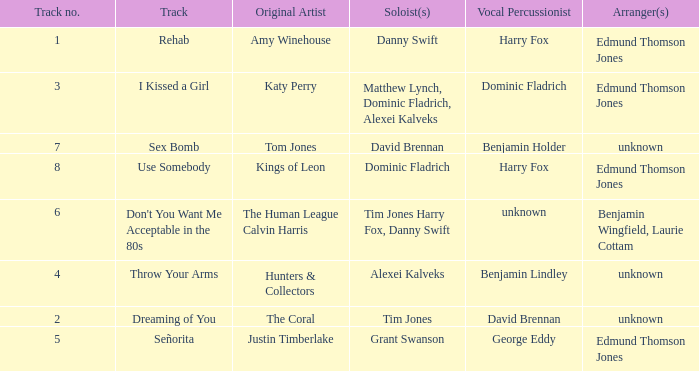Could you parse the entire table? {'header': ['Track no.', 'Track', 'Original Artist', 'Soloist(s)', 'Vocal Percussionist', 'Arranger(s)'], 'rows': [['1', 'Rehab', 'Amy Winehouse', 'Danny Swift', 'Harry Fox', 'Edmund Thomson Jones'], ['3', 'I Kissed a Girl', 'Katy Perry', 'Matthew Lynch, Dominic Fladrich, Alexei Kalveks', 'Dominic Fladrich', 'Edmund Thomson Jones'], ['7', 'Sex Bomb', 'Tom Jones', 'David Brennan', 'Benjamin Holder', 'unknown'], ['8', 'Use Somebody', 'Kings of Leon', 'Dominic Fladrich', 'Harry Fox', 'Edmund Thomson Jones'], ['6', "Don't You Want Me Acceptable in the 80s", 'The Human League Calvin Harris', 'Tim Jones Harry Fox, Danny Swift', 'unknown', 'Benjamin Wingfield, Laurie Cottam'], ['4', 'Throw Your Arms', 'Hunters & Collectors', 'Alexei Kalveks', 'Benjamin Lindley', 'unknown'], ['2', 'Dreaming of You', 'The Coral', 'Tim Jones', 'David Brennan', 'unknown'], ['5', 'Señorita', 'Justin Timberlake', 'Grant Swanson', 'George Eddy', 'Edmund Thomson Jones']]} Who is the artist where the vocal percussionist is Benjamin Holder? Tom Jones. 